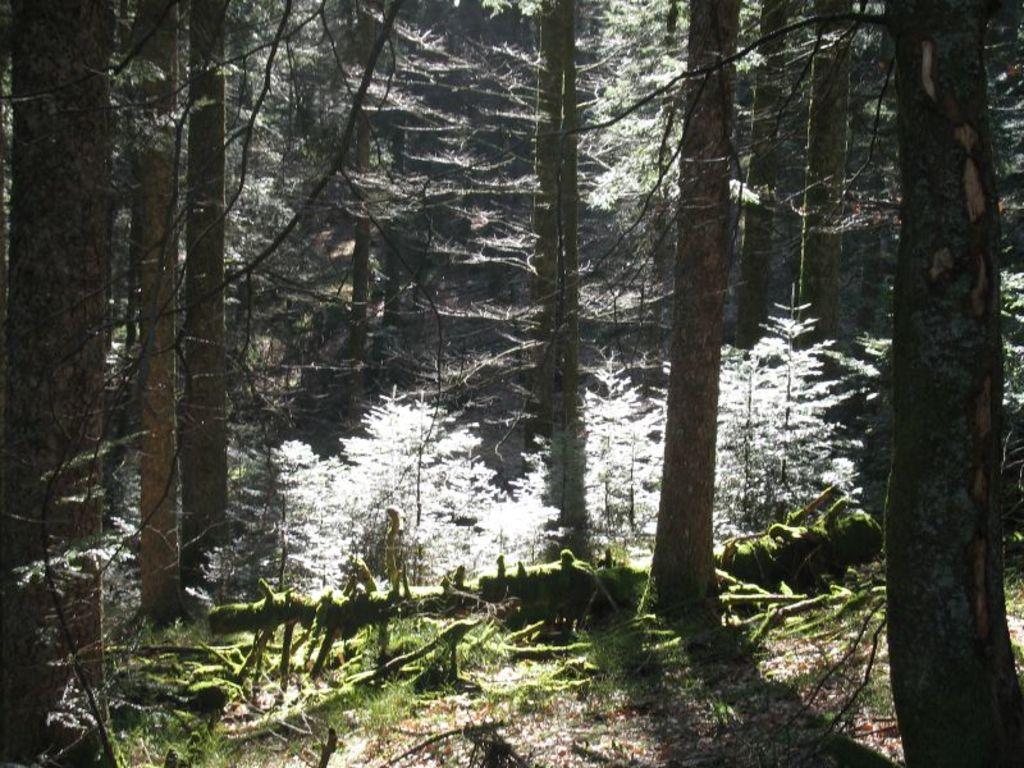In one or two sentences, can you explain what this image depicts? In this image we can see trees. At the bottom of the image there is soil and dry leaves. 